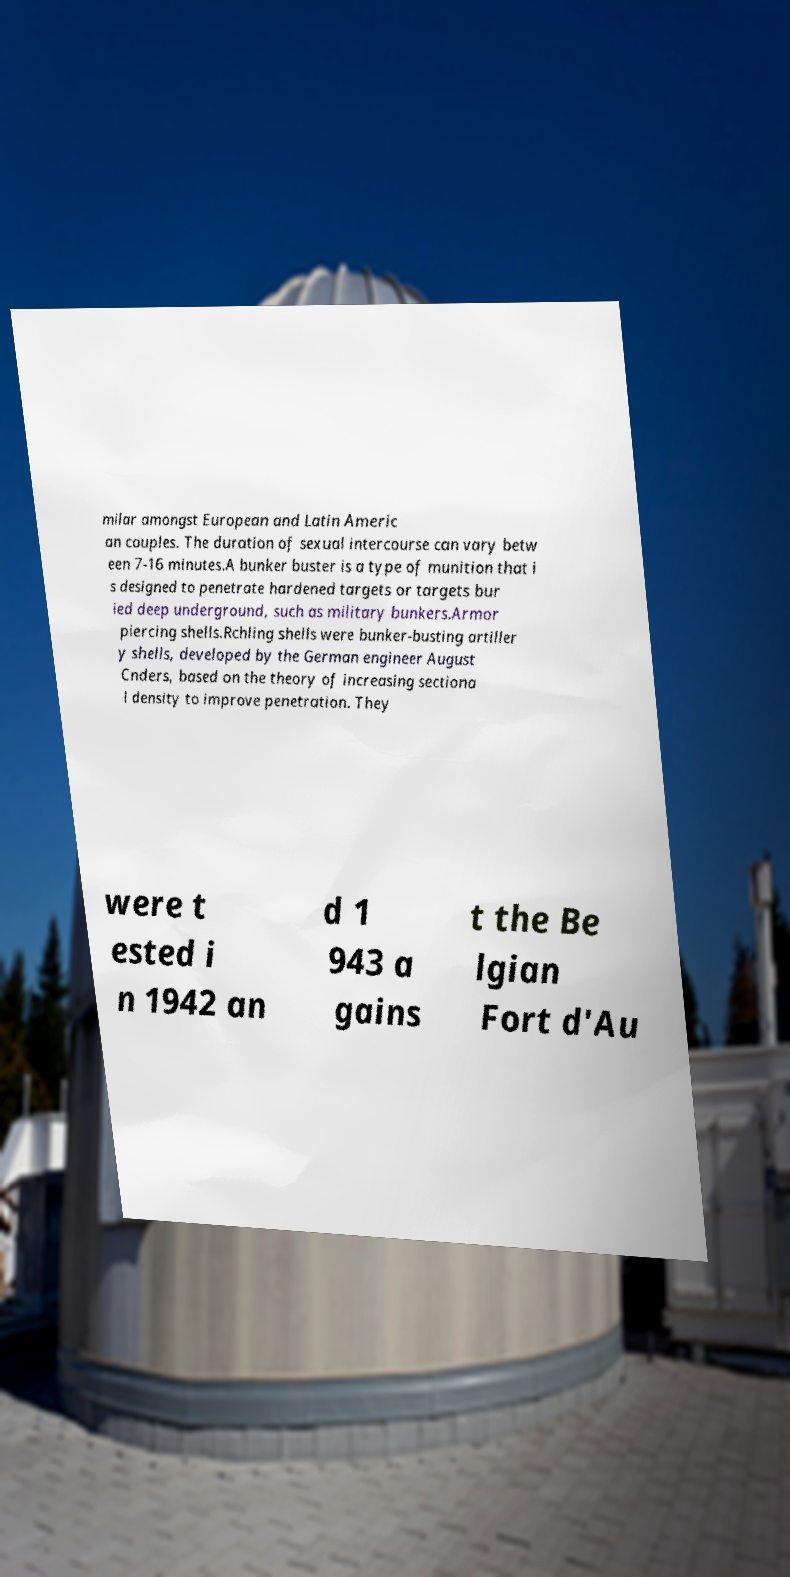What messages or text are displayed in this image? I need them in a readable, typed format. milar amongst European and Latin Americ an couples. The duration of sexual intercourse can vary betw een 7-16 minutes.A bunker buster is a type of munition that i s designed to penetrate hardened targets or targets bur ied deep underground, such as military bunkers.Armor piercing shells.Rchling shells were bunker-busting artiller y shells, developed by the German engineer August Cnders, based on the theory of increasing sectiona l density to improve penetration. They were t ested i n 1942 an d 1 943 a gains t the Be lgian Fort d'Au 